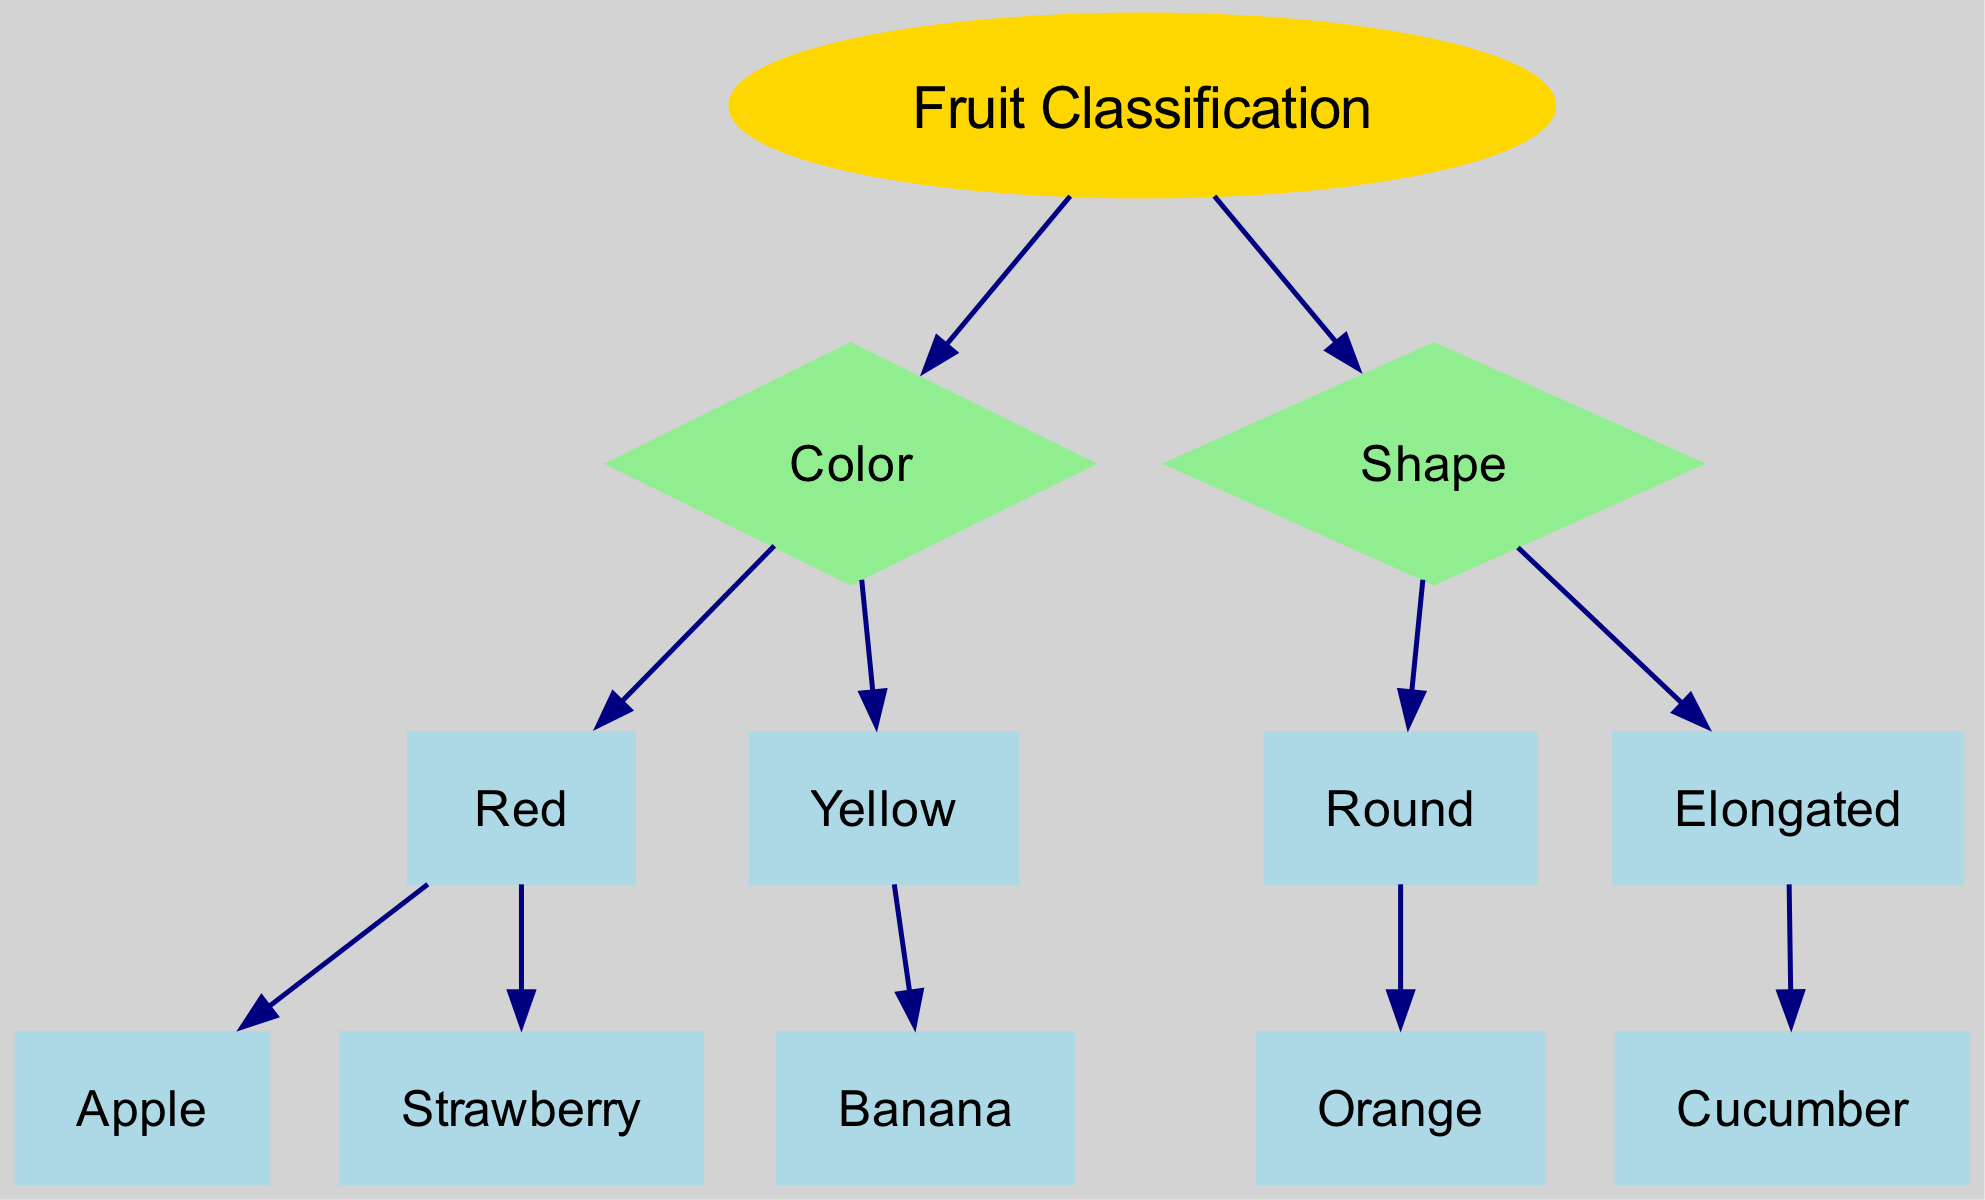What is the root node of the diagram? The root node is labeled "Fruit Classification," indicating that it serves as the starting point for the decision-making process in the diagram.
Answer: Fruit Classification How many fruits are classified under the color "Red"? There are two fruits classified under "Red": Apple and Strawberry. Thus, the count of fruits under this node is two.
Answer: 2 What shape is associated with "Banana"? In the diagram, "Banana" is classified under the "Yellow" node, and it does not have a specific shape branch. Therefore, it does not specifically relate to either "Round" or "Elongated" shapes.
Answer: None Which fruit is classified under the shape "Round"? The shape "Round" is linked to the fruit "Orange" in the diagram. It is a direct child of the "Round" node under the "Shape" classification.
Answer: Orange What is the total number of nodes in the diagram? The total nodes in the diagram include the root node, the feature nodes (Color and Shape), and all the fruit classifications. Counting these gives a total of 7 nodes: Fruit Classification, Color, Shape, Red, Yellow, Round, Elongated.
Answer: 7 If a fruit is classified as "Elongated," what fruit will it be? The "Elongated" classification has a single fruit associated with it, which is "Cucumber." Since it is the only option under this node, it directly identifies the fruit.
Answer: Cucumber Which classification leads to "Strawberry"? "Strawberry" is classified under the "Red" node, which is a child of the "Color" feature in the decision tree. The route goes from Fruit Classification to Color to Red to Strawberry.
Answer: Red How many edges are there in the diagram? The number of edges corresponds to the connections between the nodes. Each classification leads to its children. By counting each link, there are 6 edges in total.
Answer: 6 